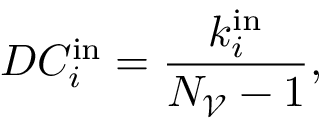Convert formula to latex. <formula><loc_0><loc_0><loc_500><loc_500>D C _ { i } ^ { i n } = \frac { k _ { i } ^ { i n } } { N _ { \ m a t h s c r { V } } - 1 } ,</formula> 